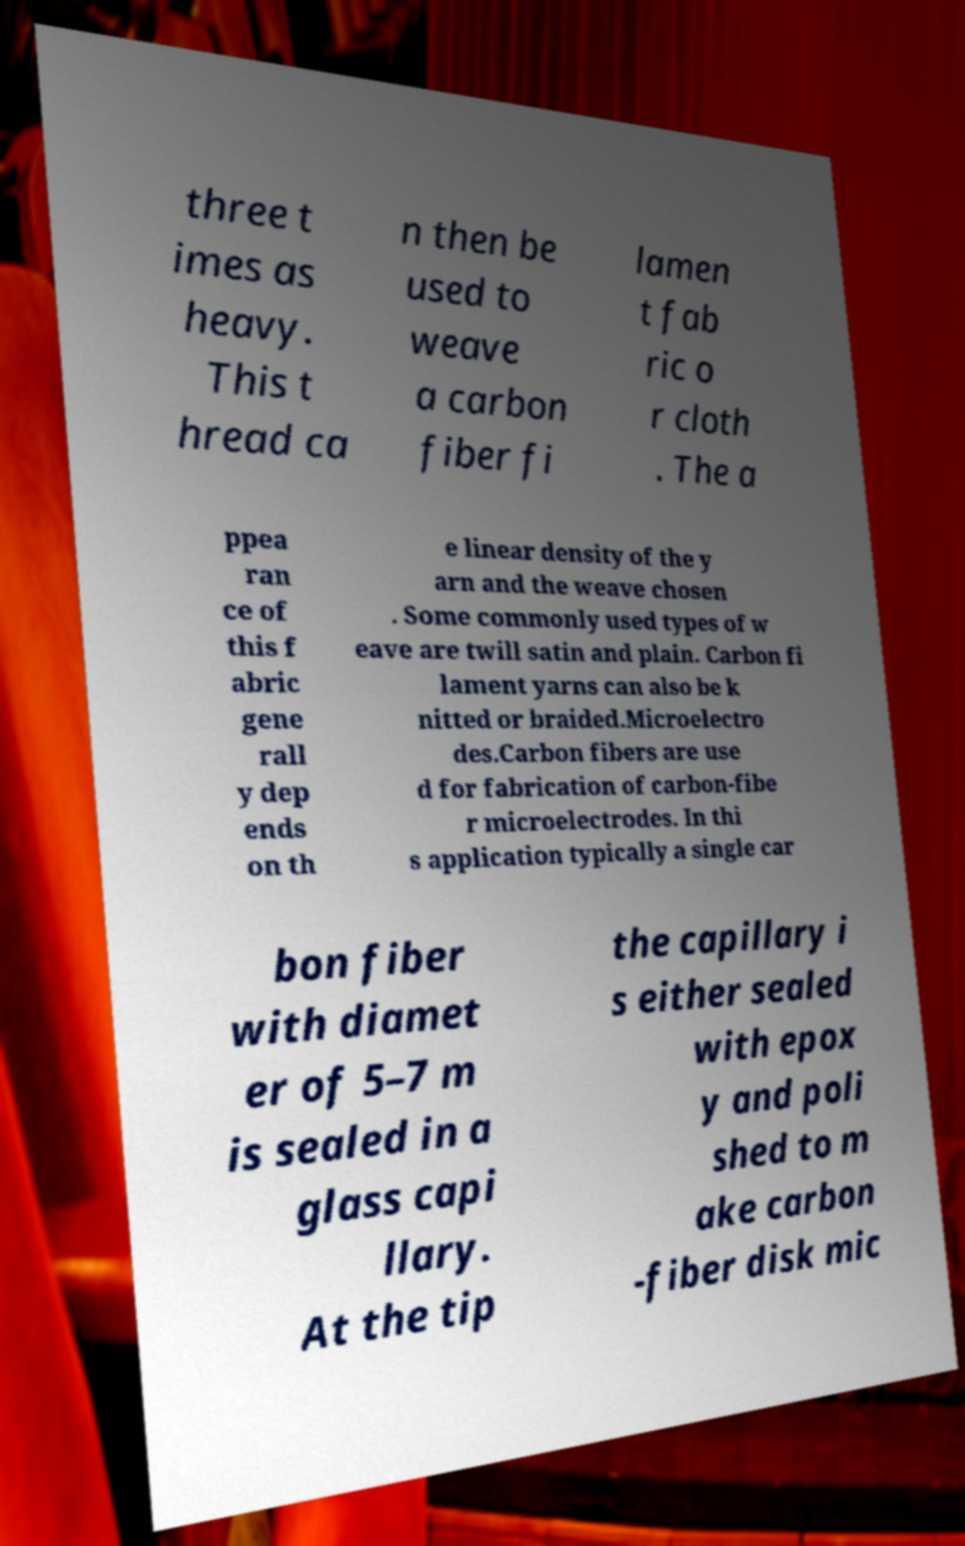Could you extract and type out the text from this image? three t imes as heavy. This t hread ca n then be used to weave a carbon fiber fi lamen t fab ric o r cloth . The a ppea ran ce of this f abric gene rall y dep ends on th e linear density of the y arn and the weave chosen . Some commonly used types of w eave are twill satin and plain. Carbon fi lament yarns can also be k nitted or braided.Microelectro des.Carbon fibers are use d for fabrication of carbon-fibe r microelectrodes. In thi s application typically a single car bon fiber with diamet er of 5–7 m is sealed in a glass capi llary. At the tip the capillary i s either sealed with epox y and poli shed to m ake carbon -fiber disk mic 